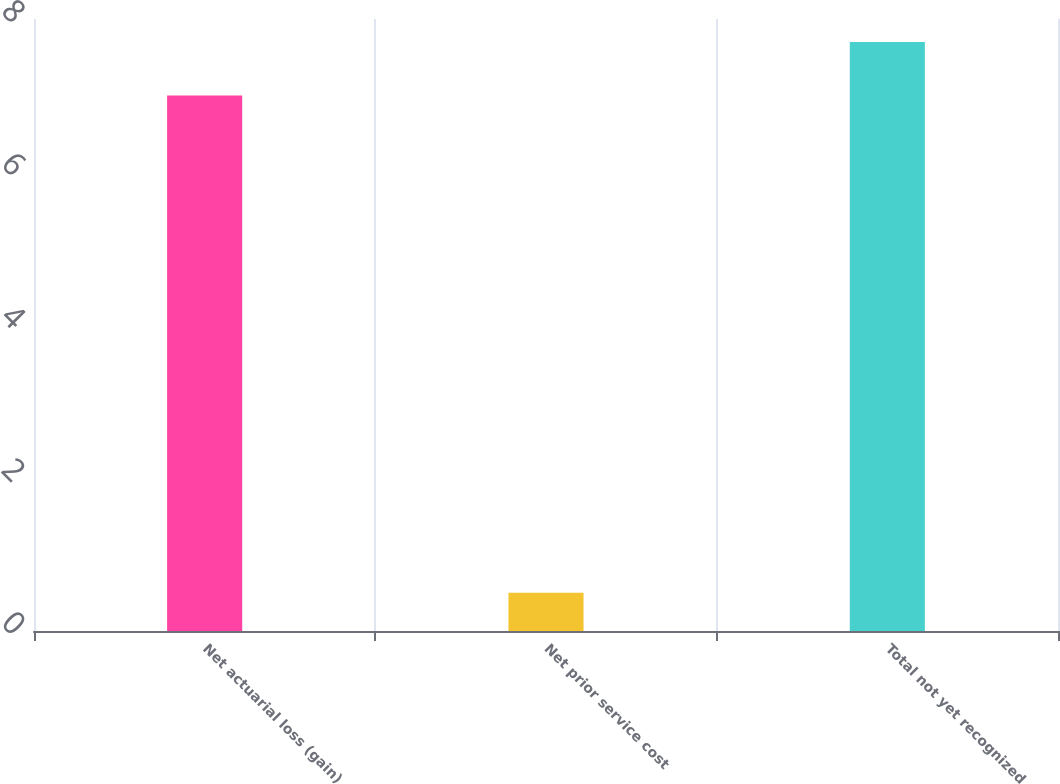<chart> <loc_0><loc_0><loc_500><loc_500><bar_chart><fcel>Net actuarial loss (gain)<fcel>Net prior service cost<fcel>Total not yet recognized<nl><fcel>7<fcel>0.5<fcel>7.7<nl></chart> 